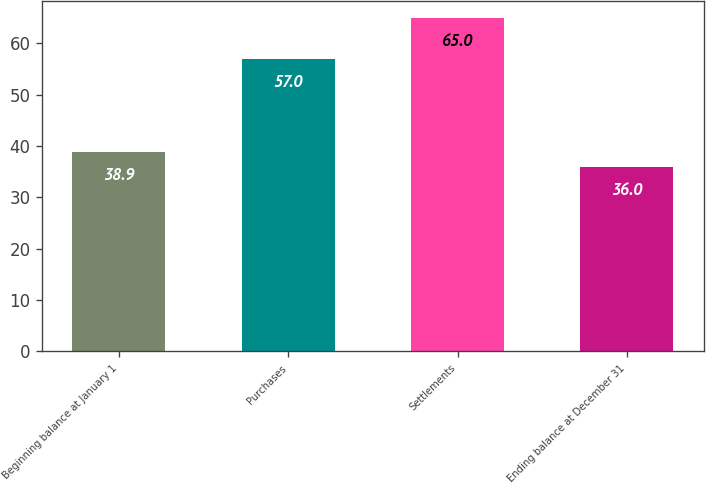Convert chart to OTSL. <chart><loc_0><loc_0><loc_500><loc_500><bar_chart><fcel>Beginning balance at January 1<fcel>Purchases<fcel>Settlements<fcel>Ending balance at December 31<nl><fcel>38.9<fcel>57<fcel>65<fcel>36<nl></chart> 